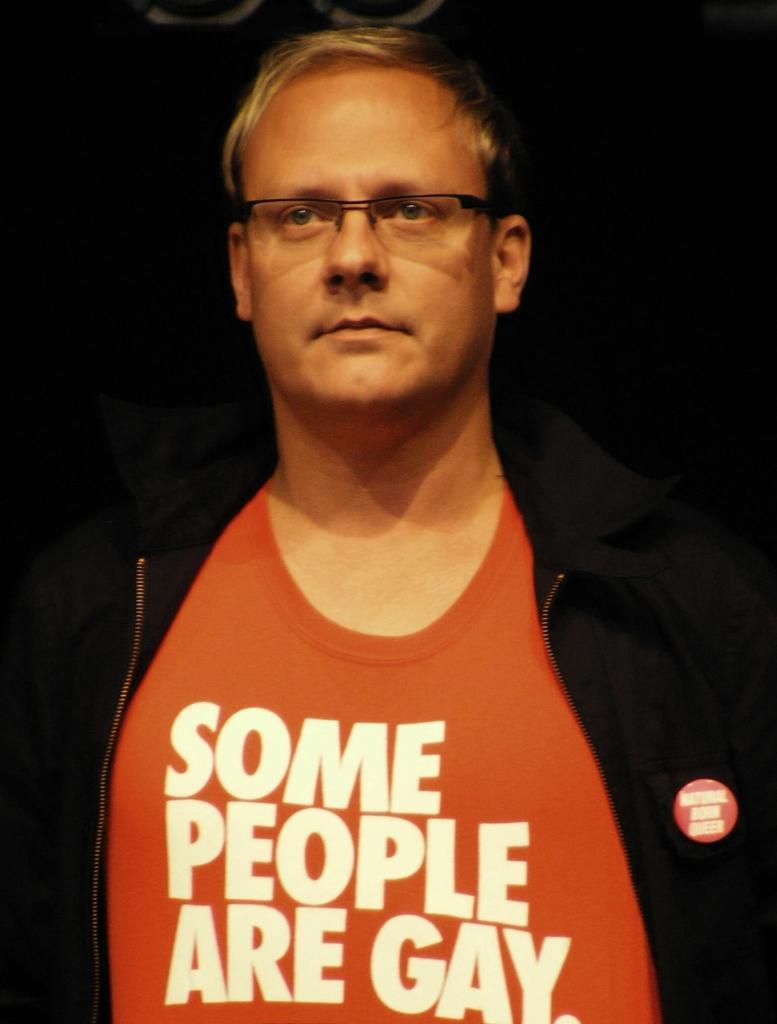Describe this image in one or two sentences. In this picture we can see a person wearing spectacles. 